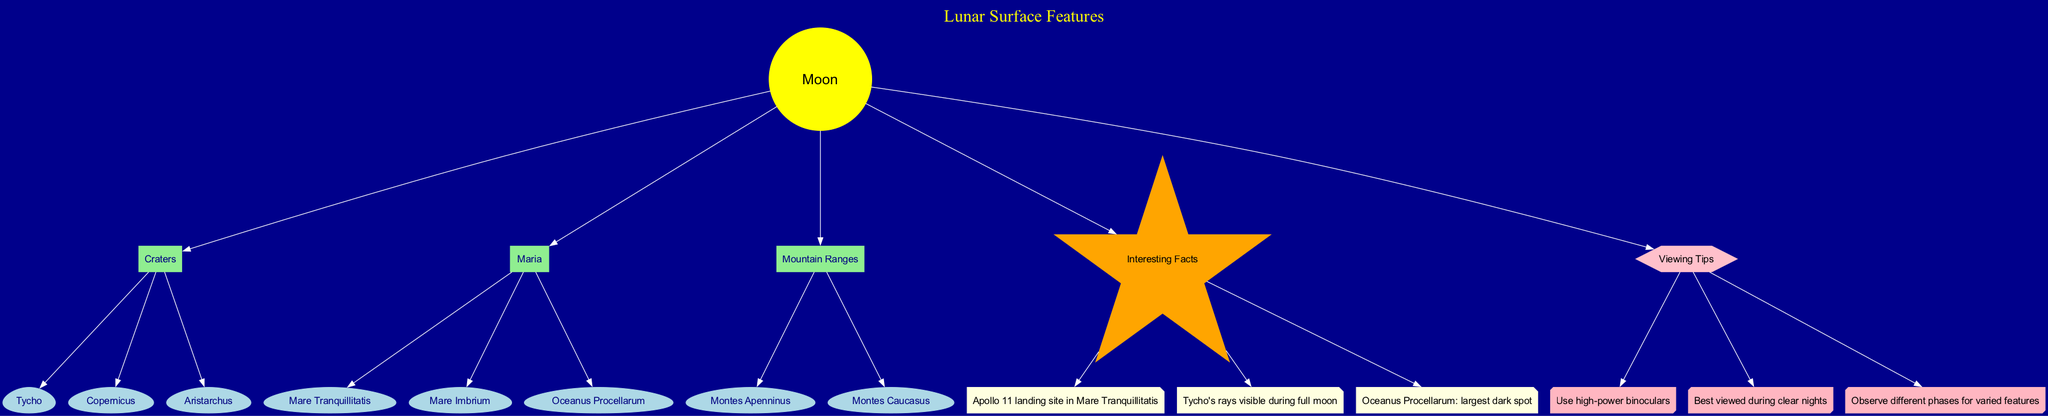What is the central element of the diagram? The central element is the "Moon" which is depicted in yellow at the center of the diagram.
Answer: Moon How many major features are listed in the diagram? The diagram lists three major features: Craters, Maria, and Mountain Ranges.
Answer: 3 Which crater is named after a famous astronomer? The crater "Copernicus" is named after the famous astronomer Nicolaus Copernicus.
Answer: Copernicus What is the largest dark spot on the Moon according to the diagram? The diagram states that "Oceanus Procellarum" is the largest dark spot on the Moon's surface.
Answer: Oceanus Procellarum How many interesting facts are provided in the diagram? The diagram contains three interesting facts related to the Moon's surface features.
Answer: 3 Which Moon feature is the landing site of Apollo 11? The landing site of Apollo 11 is located in "Mare Tranquillitatis."
Answer: Mare Tranquillitatis What type of object is Tycho classified as in the diagram? In the diagram, Tycho is classified as a crater.
Answer: Crater Which feature would be best observed during clear nights according to the tips? The tips suggest that the Moon's features, in general, are best viewed during clear nights.
Answer: Moon's features What color is used to represent interesting facts in the diagram? Interesting facts are represented with nodes colored light yellow.
Answer: Light yellow 